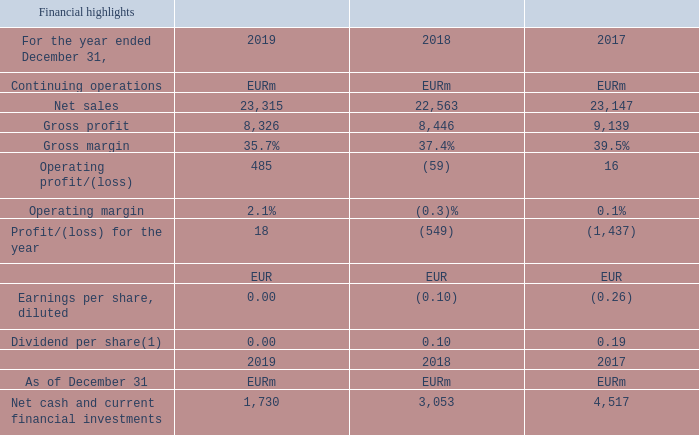(1) No dividend is proposed by the Board of Directors related to the financial year 2019.
(2) Includes net sales to other segments.
The figures are derived from our consolidated financial
statements prepared in accordance with IFRS. Year-on-year
change is in parenthesis.
All Nokia Technologies IPR and Licensing net sales are allocated to Finland.
Nokia Techonologies IPR and Licensing net sales are allocated to which country? Finland. What is the proposed dividend for financial year 2019?  0.00. What is the Gross margin for year ending 2019? 35.7%. What is the increase / (decrease) in Gross profit from 2018 to 2019?
Answer scale should be: million. 8,326 - 8,446
Answer: -120. What is the average Profit/(loss) for the year in the last 3 years?
Answer scale should be: million. (18 - 549 - 1,437) / 3
Answer: -656. What is the percentage increase / (decrease) in Net cash and current financial investments from 2018 to 2019?
Answer scale should be: percent. 1,730 / 3,053 - 1
Answer: -43.33. 